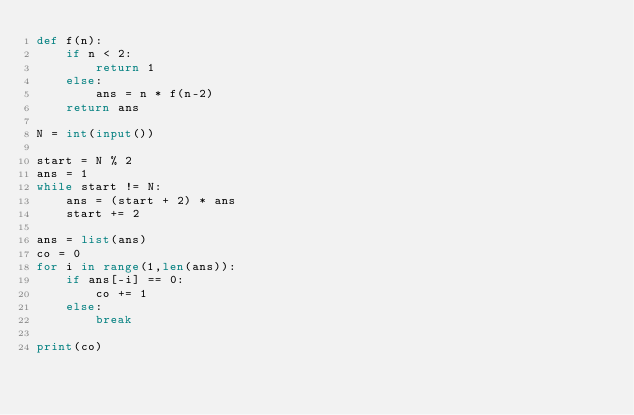Convert code to text. <code><loc_0><loc_0><loc_500><loc_500><_Python_>def f(n):
    if n < 2:
        return 1
    else:
        ans = n * f(n-2)
    return ans

N = int(input())

start = N % 2
ans = 1
while start != N:
    ans = (start + 2) * ans
    start += 2

ans = list(ans)
co = 0
for i in range(1,len(ans)):
    if ans[-i] == 0:
        co += 1
    else:
        break

print(co)</code> 